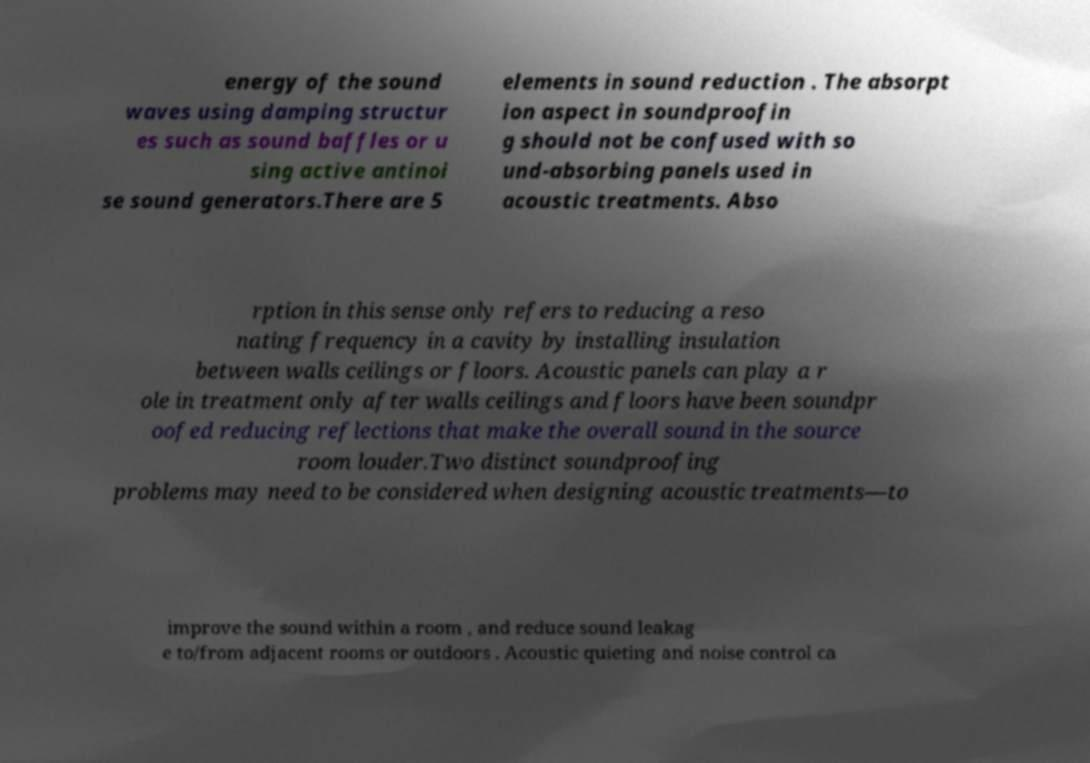There's text embedded in this image that I need extracted. Can you transcribe it verbatim? energy of the sound waves using damping structur es such as sound baffles or u sing active antinoi se sound generators.There are 5 elements in sound reduction . The absorpt ion aspect in soundproofin g should not be confused with so und-absorbing panels used in acoustic treatments. Abso rption in this sense only refers to reducing a reso nating frequency in a cavity by installing insulation between walls ceilings or floors. Acoustic panels can play a r ole in treatment only after walls ceilings and floors have been soundpr oofed reducing reflections that make the overall sound in the source room louder.Two distinct soundproofing problems may need to be considered when designing acoustic treatments—to improve the sound within a room , and reduce sound leakag e to/from adjacent rooms or outdoors . Acoustic quieting and noise control ca 